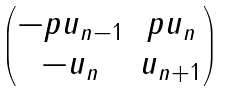Convert formula to latex. <formula><loc_0><loc_0><loc_500><loc_500>\begin{pmatrix} - p u _ { n - 1 } & p u _ { n } \\ - u _ { n } & u _ { n + 1 } \end{pmatrix}</formula> 